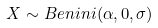<formula> <loc_0><loc_0><loc_500><loc_500>X \sim B e n i n i ( \alpha , 0 , \sigma )</formula> 